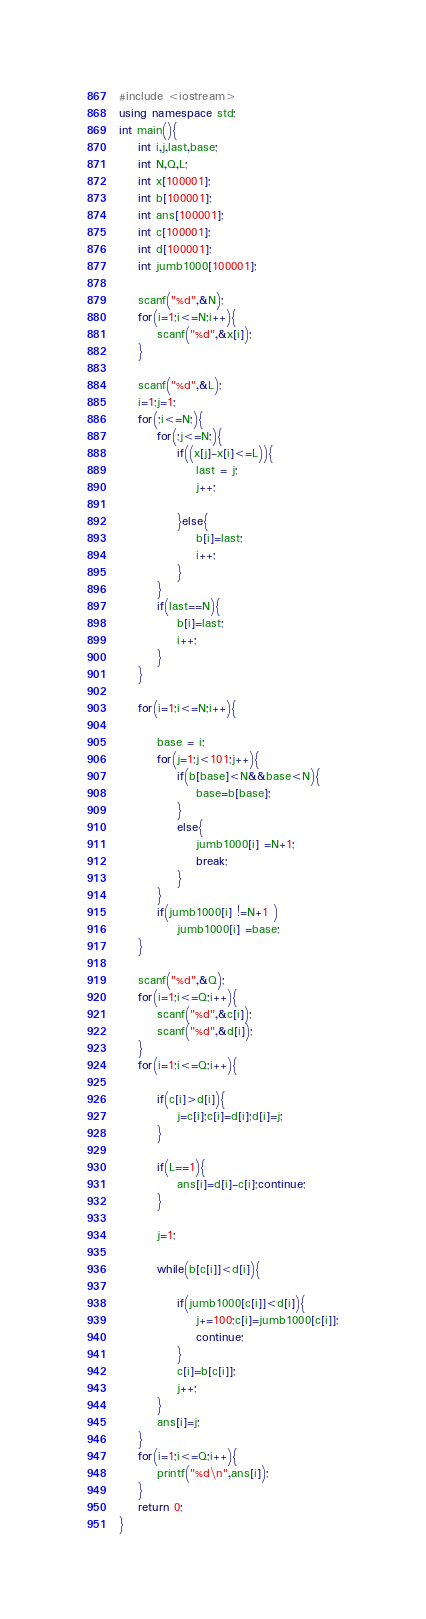<code> <loc_0><loc_0><loc_500><loc_500><_C++_>#include <iostream>
using namespace std;
int main(){
	int i,j,last,base;
	int N,Q,L;
	int x[100001];
	int b[100001];
	int ans[100001];
	int c[100001];
	int d[100001];
	int jumb1000[100001];
		
	scanf("%d",&N);
	for(i=1;i<=N;i++){
		scanf("%d",&x[i]);
	}
	
	scanf("%d",&L);
	i=1;j=1;
	for(;i<=N;){
		for(;j<=N;){
			if((x[j]-x[i]<=L)){
				last = j;
				j++;
				
			}else{
				b[i]=last;
				i++;
			}
		}
		if(last==N){
			b[i]=last;
			i++;
		}
	}
	
	for(i=1;i<=N;i++){
		
		base = i;
		for(j=1;j<101;j++){
			if(b[base]<N&&base<N){
				base=b[base];
			}
			else{
				jumb1000[i] =N+1;
				break;
			}
		}
		if(jumb1000[i] !=N+1 )
			jumb1000[i] =base;
	}
	
	scanf("%d",&Q);
	for(i=1;i<=Q;i++){
		scanf("%d",&c[i]);
		scanf("%d",&d[i]);
	}
	for(i=1;i<=Q;i++){

		if(c[i]>d[i]){
			j=c[i];c[i]=d[i];d[i]=j;
		}

		if(L==1){
			ans[i]=d[i]-c[i];continue;
		}
		
		j=1;
		
		while(b[c[i]]<d[i]){
			
			if(jumb1000[c[i]]<d[i]){
				j+=100;c[i]=jumb1000[c[i]];
				continue;
			}
			c[i]=b[c[i]];
			j++;
		}
		ans[i]=j;
	}
	for(i=1;i<=Q;i++){
		printf("%d\n",ans[i]);
	}
	return 0;
}</code> 